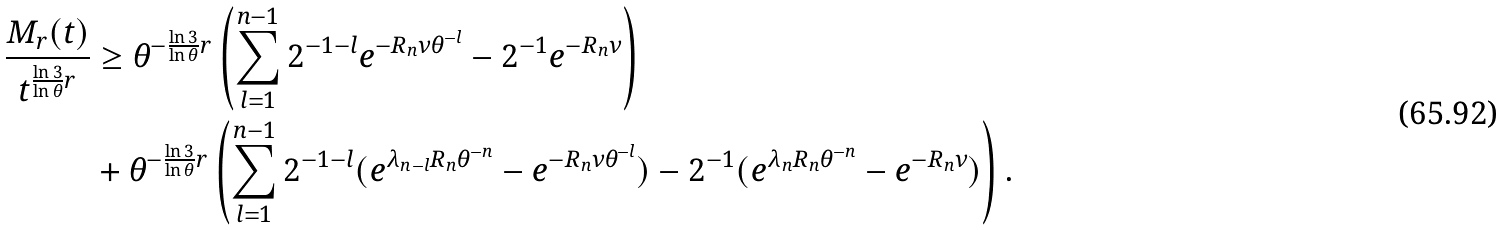Convert formula to latex. <formula><loc_0><loc_0><loc_500><loc_500>\frac { M _ { r } ( t ) } { t ^ { \frac { \ln 3 } { \ln \theta } r } } & \geq \theta ^ { - \frac { \ln 3 } { \ln \theta } r } \left ( \sum _ { l = 1 } ^ { n - 1 } 2 ^ { - 1 - l } e ^ { - R _ { n } \nu \theta ^ { - l } } - 2 ^ { - 1 } e ^ { - R _ { n } \nu } \right ) \\ & + \theta ^ { - \frac { \ln 3 } { \ln \theta } r } \left ( \sum _ { l = 1 } ^ { n - 1 } 2 ^ { - 1 - l } ( e ^ { \lambda _ { n - l } R _ { n } \theta ^ { - n } } - e ^ { - R _ { n } \nu \theta ^ { - l } } ) - 2 ^ { - 1 } ( e ^ { \lambda _ { n } R _ { n } \theta ^ { - n } } - e ^ { - R _ { n } \nu } ) \right ) .</formula> 